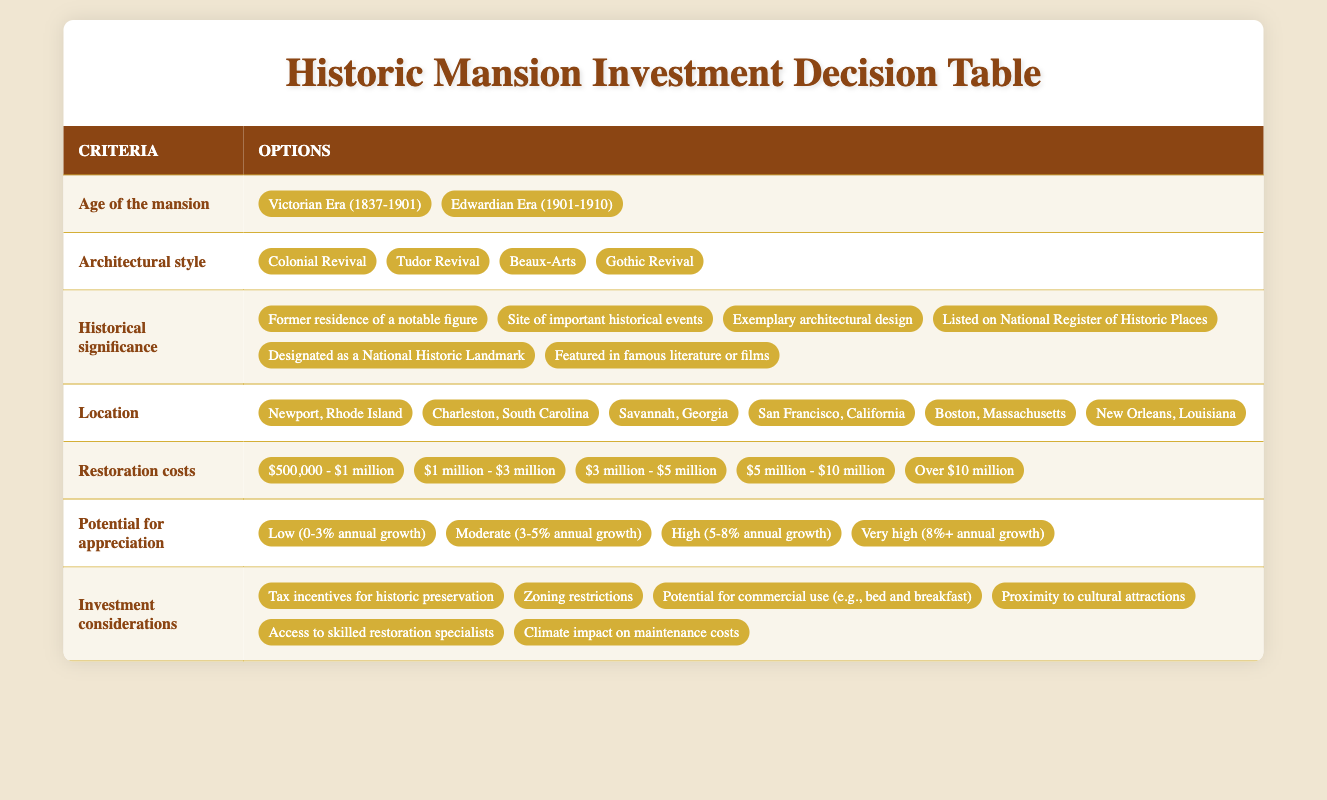What age range do most of the mansions fall into? The table presents options for the age of the mansion, specifically "Victorian Era (1837-1901)" and "Edwardian Era (1901-1910)". These are the two age ranges listed, indicating that most options are from the 19th and early 20th centuries.
Answer: 19th and early 20th centuries Which architectural style has the most options available? The architectural style section presents four options: Colonial Revival, Tudor Revival, Beaux-Arts, and Gothic Revival. None of the other criteria provide as many options; the maximum is six for historical significance but fewer for the others.
Answer: Architectural style has 4 options Is there a location associated with a high potential for appreciation? The table lists various locations but does not directly correlate them with appreciation potential. Therefore, it cannot be determined if one of the presented locations is associated with high appreciation without further data linking specific locations to appreciation metrics.
Answer: No direct correlation available How many historical significance options are there? The historical significance row in the table lists six specific options, including various types of notable associations with historical events or figures. So, to find the total, we simply count these listed options.
Answer: 6 If a mansion is located in Savannah, GA, what is the restoration cost range that could likely apply based on the options? The table lists restoration costs that range from $500,000 to over $10 million. For all listed properties, this means that any mansion, including one in Savannah, GA, could have restoration costs anywhere within this broad range.
Answer: $500,000 to over $10 million Are there investment considerations specifically related to climate? The table clearly lists "Climate impact on maintenance costs" as one of the investment considerations, indicating that climate-related factors are included in the selection criteria for investing in historic mansions.
Answer: Yes, it is listed What is the average restoration cost range for all options listed? The restoration costs listed span five categories. To find their average, we would take the central point of each band (e.g., $750,000 for the first, $2 million for the second, etc.) and average these five figures. After calculating the average of these five bends, we find it to be approximately within the overall range of $3 million to $5 million.
Answer: $3 million to $5 million How does historical significance impact selecting a mansion? While the table provides various options regarding historical significance, it does not explicitly show how these factors impact selection. However, the inclusion of options like "Listed on National Register of Historic Places" suggests they might contribute positively to the overall value and attractiveness of the mansion. So, one could infer that historical significance is a crucial selection factor.
Answer: Implied positive impact on value 